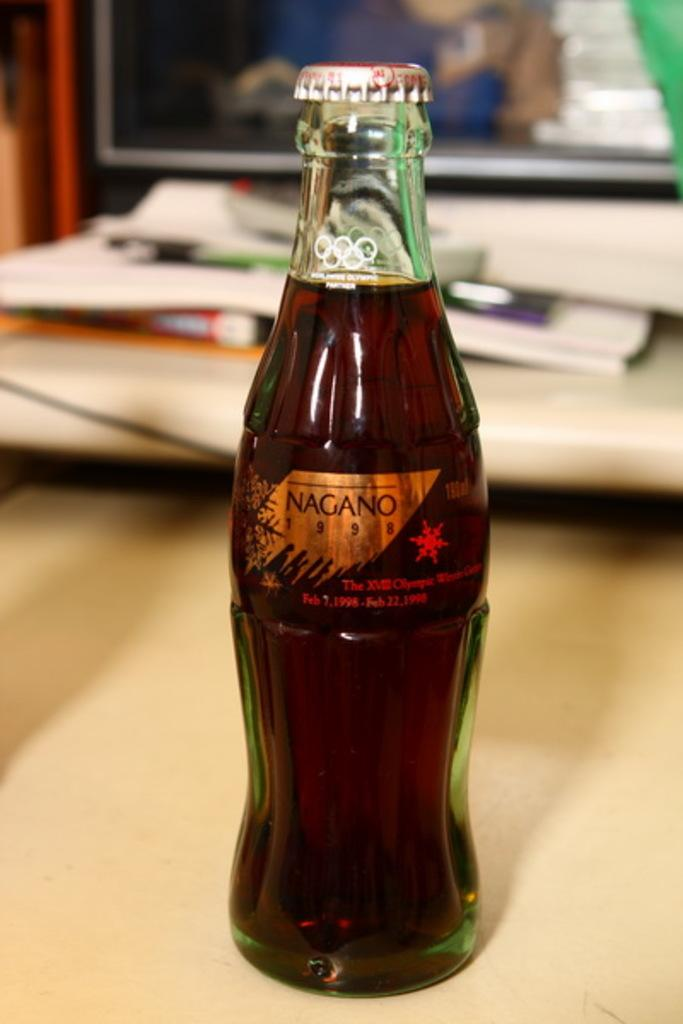<image>
Render a clear and concise summary of the photo. A clear bottle of Nagano from 1998 with cap still on it. 